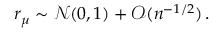Convert formula to latex. <formula><loc_0><loc_0><loc_500><loc_500>r _ { \mu } \sim \mathcal { N } ( 0 , 1 ) + \mathcal { O } ( n ^ { - 1 / 2 } ) \, .</formula> 